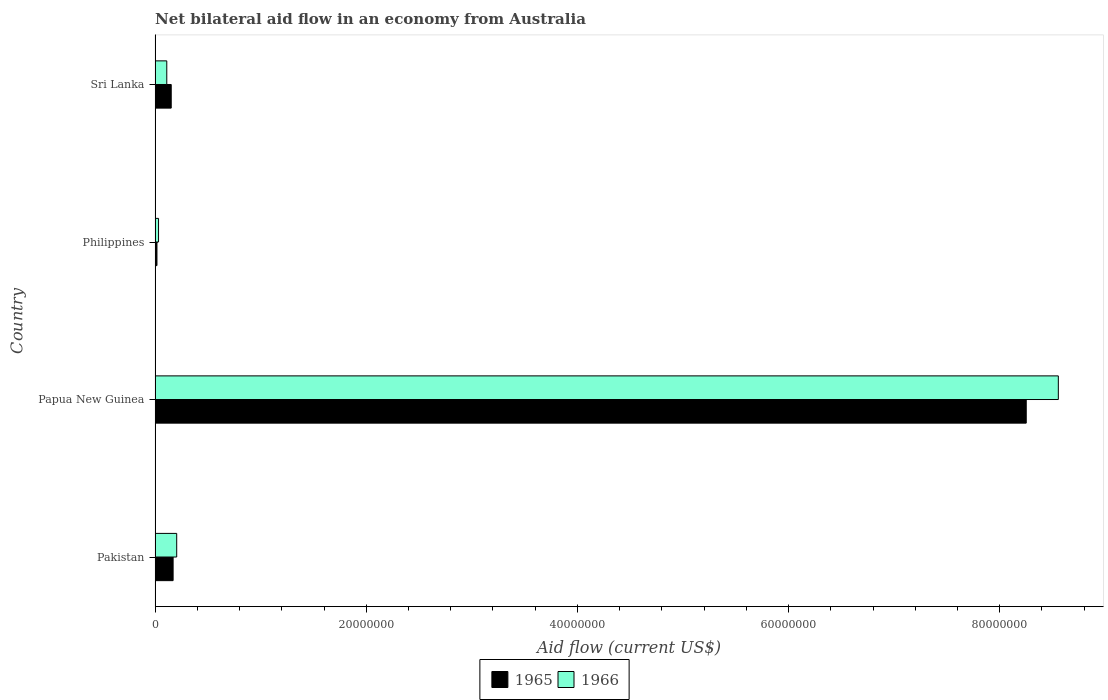How many bars are there on the 4th tick from the top?
Give a very brief answer. 2. In how many cases, is the number of bars for a given country not equal to the number of legend labels?
Provide a short and direct response. 0. What is the net bilateral aid flow in 1965 in Sri Lanka?
Offer a very short reply. 1.53e+06. Across all countries, what is the maximum net bilateral aid flow in 1966?
Provide a short and direct response. 8.56e+07. Across all countries, what is the minimum net bilateral aid flow in 1965?
Provide a short and direct response. 1.80e+05. In which country was the net bilateral aid flow in 1965 maximum?
Give a very brief answer. Papua New Guinea. In which country was the net bilateral aid flow in 1965 minimum?
Your response must be concise. Philippines. What is the total net bilateral aid flow in 1965 in the graph?
Make the answer very short. 8.59e+07. What is the difference between the net bilateral aid flow in 1965 in Pakistan and that in Papua New Guinea?
Make the answer very short. -8.08e+07. What is the difference between the net bilateral aid flow in 1966 in Pakistan and the net bilateral aid flow in 1965 in Papua New Guinea?
Provide a short and direct response. -8.05e+07. What is the average net bilateral aid flow in 1965 per country?
Give a very brief answer. 2.15e+07. What is the difference between the net bilateral aid flow in 1966 and net bilateral aid flow in 1965 in Philippines?
Give a very brief answer. 1.50e+05. What is the ratio of the net bilateral aid flow in 1965 in Pakistan to that in Philippines?
Offer a very short reply. 9.5. Is the difference between the net bilateral aid flow in 1966 in Philippines and Sri Lanka greater than the difference between the net bilateral aid flow in 1965 in Philippines and Sri Lanka?
Provide a succinct answer. Yes. What is the difference between the highest and the second highest net bilateral aid flow in 1966?
Offer a very short reply. 8.35e+07. What is the difference between the highest and the lowest net bilateral aid flow in 1966?
Your response must be concise. 8.52e+07. In how many countries, is the net bilateral aid flow in 1966 greater than the average net bilateral aid flow in 1966 taken over all countries?
Offer a terse response. 1. What does the 2nd bar from the top in Pakistan represents?
Make the answer very short. 1965. What does the 1st bar from the bottom in Pakistan represents?
Provide a succinct answer. 1965. How many bars are there?
Your answer should be compact. 8. Are all the bars in the graph horizontal?
Give a very brief answer. Yes. How many countries are there in the graph?
Provide a short and direct response. 4. What is the difference between two consecutive major ticks on the X-axis?
Ensure brevity in your answer.  2.00e+07. Are the values on the major ticks of X-axis written in scientific E-notation?
Your response must be concise. No. Where does the legend appear in the graph?
Make the answer very short. Bottom center. How many legend labels are there?
Make the answer very short. 2. What is the title of the graph?
Provide a short and direct response. Net bilateral aid flow in an economy from Australia. What is the label or title of the X-axis?
Offer a terse response. Aid flow (current US$). What is the label or title of the Y-axis?
Ensure brevity in your answer.  Country. What is the Aid flow (current US$) of 1965 in Pakistan?
Give a very brief answer. 1.71e+06. What is the Aid flow (current US$) of 1966 in Pakistan?
Provide a succinct answer. 2.05e+06. What is the Aid flow (current US$) of 1965 in Papua New Guinea?
Your response must be concise. 8.25e+07. What is the Aid flow (current US$) in 1966 in Papua New Guinea?
Give a very brief answer. 8.56e+07. What is the Aid flow (current US$) of 1965 in Sri Lanka?
Give a very brief answer. 1.53e+06. What is the Aid flow (current US$) in 1966 in Sri Lanka?
Provide a succinct answer. 1.11e+06. Across all countries, what is the maximum Aid flow (current US$) of 1965?
Give a very brief answer. 8.25e+07. Across all countries, what is the maximum Aid flow (current US$) in 1966?
Ensure brevity in your answer.  8.56e+07. What is the total Aid flow (current US$) in 1965 in the graph?
Your answer should be very brief. 8.59e+07. What is the total Aid flow (current US$) in 1966 in the graph?
Offer a terse response. 8.90e+07. What is the difference between the Aid flow (current US$) in 1965 in Pakistan and that in Papua New Guinea?
Your answer should be very brief. -8.08e+07. What is the difference between the Aid flow (current US$) of 1966 in Pakistan and that in Papua New Guinea?
Your answer should be compact. -8.35e+07. What is the difference between the Aid flow (current US$) in 1965 in Pakistan and that in Philippines?
Your response must be concise. 1.53e+06. What is the difference between the Aid flow (current US$) of 1966 in Pakistan and that in Philippines?
Your answer should be very brief. 1.72e+06. What is the difference between the Aid flow (current US$) of 1965 in Pakistan and that in Sri Lanka?
Your answer should be compact. 1.80e+05. What is the difference between the Aid flow (current US$) of 1966 in Pakistan and that in Sri Lanka?
Ensure brevity in your answer.  9.40e+05. What is the difference between the Aid flow (current US$) in 1965 in Papua New Guinea and that in Philippines?
Your answer should be compact. 8.23e+07. What is the difference between the Aid flow (current US$) of 1966 in Papua New Guinea and that in Philippines?
Your response must be concise. 8.52e+07. What is the difference between the Aid flow (current US$) in 1965 in Papua New Guinea and that in Sri Lanka?
Make the answer very short. 8.10e+07. What is the difference between the Aid flow (current US$) in 1966 in Papua New Guinea and that in Sri Lanka?
Offer a very short reply. 8.44e+07. What is the difference between the Aid flow (current US$) in 1965 in Philippines and that in Sri Lanka?
Your answer should be very brief. -1.35e+06. What is the difference between the Aid flow (current US$) in 1966 in Philippines and that in Sri Lanka?
Give a very brief answer. -7.80e+05. What is the difference between the Aid flow (current US$) in 1965 in Pakistan and the Aid flow (current US$) in 1966 in Papua New Guinea?
Offer a terse response. -8.38e+07. What is the difference between the Aid flow (current US$) of 1965 in Pakistan and the Aid flow (current US$) of 1966 in Philippines?
Ensure brevity in your answer.  1.38e+06. What is the difference between the Aid flow (current US$) of 1965 in Pakistan and the Aid flow (current US$) of 1966 in Sri Lanka?
Make the answer very short. 6.00e+05. What is the difference between the Aid flow (current US$) in 1965 in Papua New Guinea and the Aid flow (current US$) in 1966 in Philippines?
Ensure brevity in your answer.  8.22e+07. What is the difference between the Aid flow (current US$) in 1965 in Papua New Guinea and the Aid flow (current US$) in 1966 in Sri Lanka?
Your response must be concise. 8.14e+07. What is the difference between the Aid flow (current US$) of 1965 in Philippines and the Aid flow (current US$) of 1966 in Sri Lanka?
Give a very brief answer. -9.30e+05. What is the average Aid flow (current US$) in 1965 per country?
Offer a very short reply. 2.15e+07. What is the average Aid flow (current US$) in 1966 per country?
Make the answer very short. 2.23e+07. What is the difference between the Aid flow (current US$) in 1965 and Aid flow (current US$) in 1966 in Papua New Guinea?
Your answer should be very brief. -3.04e+06. What is the difference between the Aid flow (current US$) of 1965 and Aid flow (current US$) of 1966 in Philippines?
Give a very brief answer. -1.50e+05. What is the difference between the Aid flow (current US$) in 1965 and Aid flow (current US$) in 1966 in Sri Lanka?
Keep it short and to the point. 4.20e+05. What is the ratio of the Aid flow (current US$) in 1965 in Pakistan to that in Papua New Guinea?
Your answer should be very brief. 0.02. What is the ratio of the Aid flow (current US$) of 1966 in Pakistan to that in Papua New Guinea?
Ensure brevity in your answer.  0.02. What is the ratio of the Aid flow (current US$) of 1966 in Pakistan to that in Philippines?
Your answer should be compact. 6.21. What is the ratio of the Aid flow (current US$) in 1965 in Pakistan to that in Sri Lanka?
Provide a short and direct response. 1.12. What is the ratio of the Aid flow (current US$) in 1966 in Pakistan to that in Sri Lanka?
Provide a short and direct response. 1.85. What is the ratio of the Aid flow (current US$) of 1965 in Papua New Guinea to that in Philippines?
Your response must be concise. 458.39. What is the ratio of the Aid flow (current US$) in 1966 in Papua New Guinea to that in Philippines?
Provide a succinct answer. 259.24. What is the ratio of the Aid flow (current US$) in 1965 in Papua New Guinea to that in Sri Lanka?
Your response must be concise. 53.93. What is the ratio of the Aid flow (current US$) of 1966 in Papua New Guinea to that in Sri Lanka?
Your answer should be very brief. 77.07. What is the ratio of the Aid flow (current US$) in 1965 in Philippines to that in Sri Lanka?
Provide a short and direct response. 0.12. What is the ratio of the Aid flow (current US$) in 1966 in Philippines to that in Sri Lanka?
Provide a short and direct response. 0.3. What is the difference between the highest and the second highest Aid flow (current US$) of 1965?
Provide a short and direct response. 8.08e+07. What is the difference between the highest and the second highest Aid flow (current US$) in 1966?
Ensure brevity in your answer.  8.35e+07. What is the difference between the highest and the lowest Aid flow (current US$) of 1965?
Give a very brief answer. 8.23e+07. What is the difference between the highest and the lowest Aid flow (current US$) in 1966?
Your answer should be very brief. 8.52e+07. 